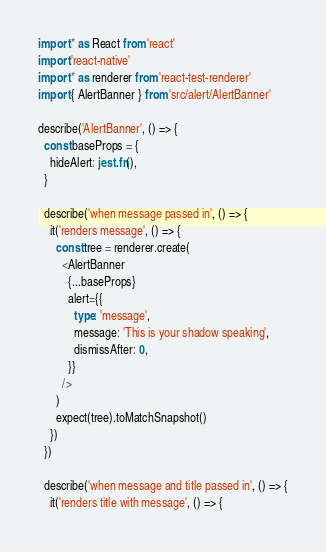<code> <loc_0><loc_0><loc_500><loc_500><_TypeScript_>import * as React from 'react'
import 'react-native'
import * as renderer from 'react-test-renderer'
import { AlertBanner } from 'src/alert/AlertBanner'

describe('AlertBanner', () => {
  const baseProps = {
    hideAlert: jest.fn(),
  }

  describe('when message passed in', () => {
    it('renders message', () => {
      const tree = renderer.create(
        <AlertBanner
          {...baseProps}
          alert={{
            type: 'message',
            message: 'This is your shadow speaking',
            dismissAfter: 0,
          }}
        />
      )
      expect(tree).toMatchSnapshot()
    })
  })

  describe('when message and title passed in', () => {
    it('renders title with message', () => {</code> 